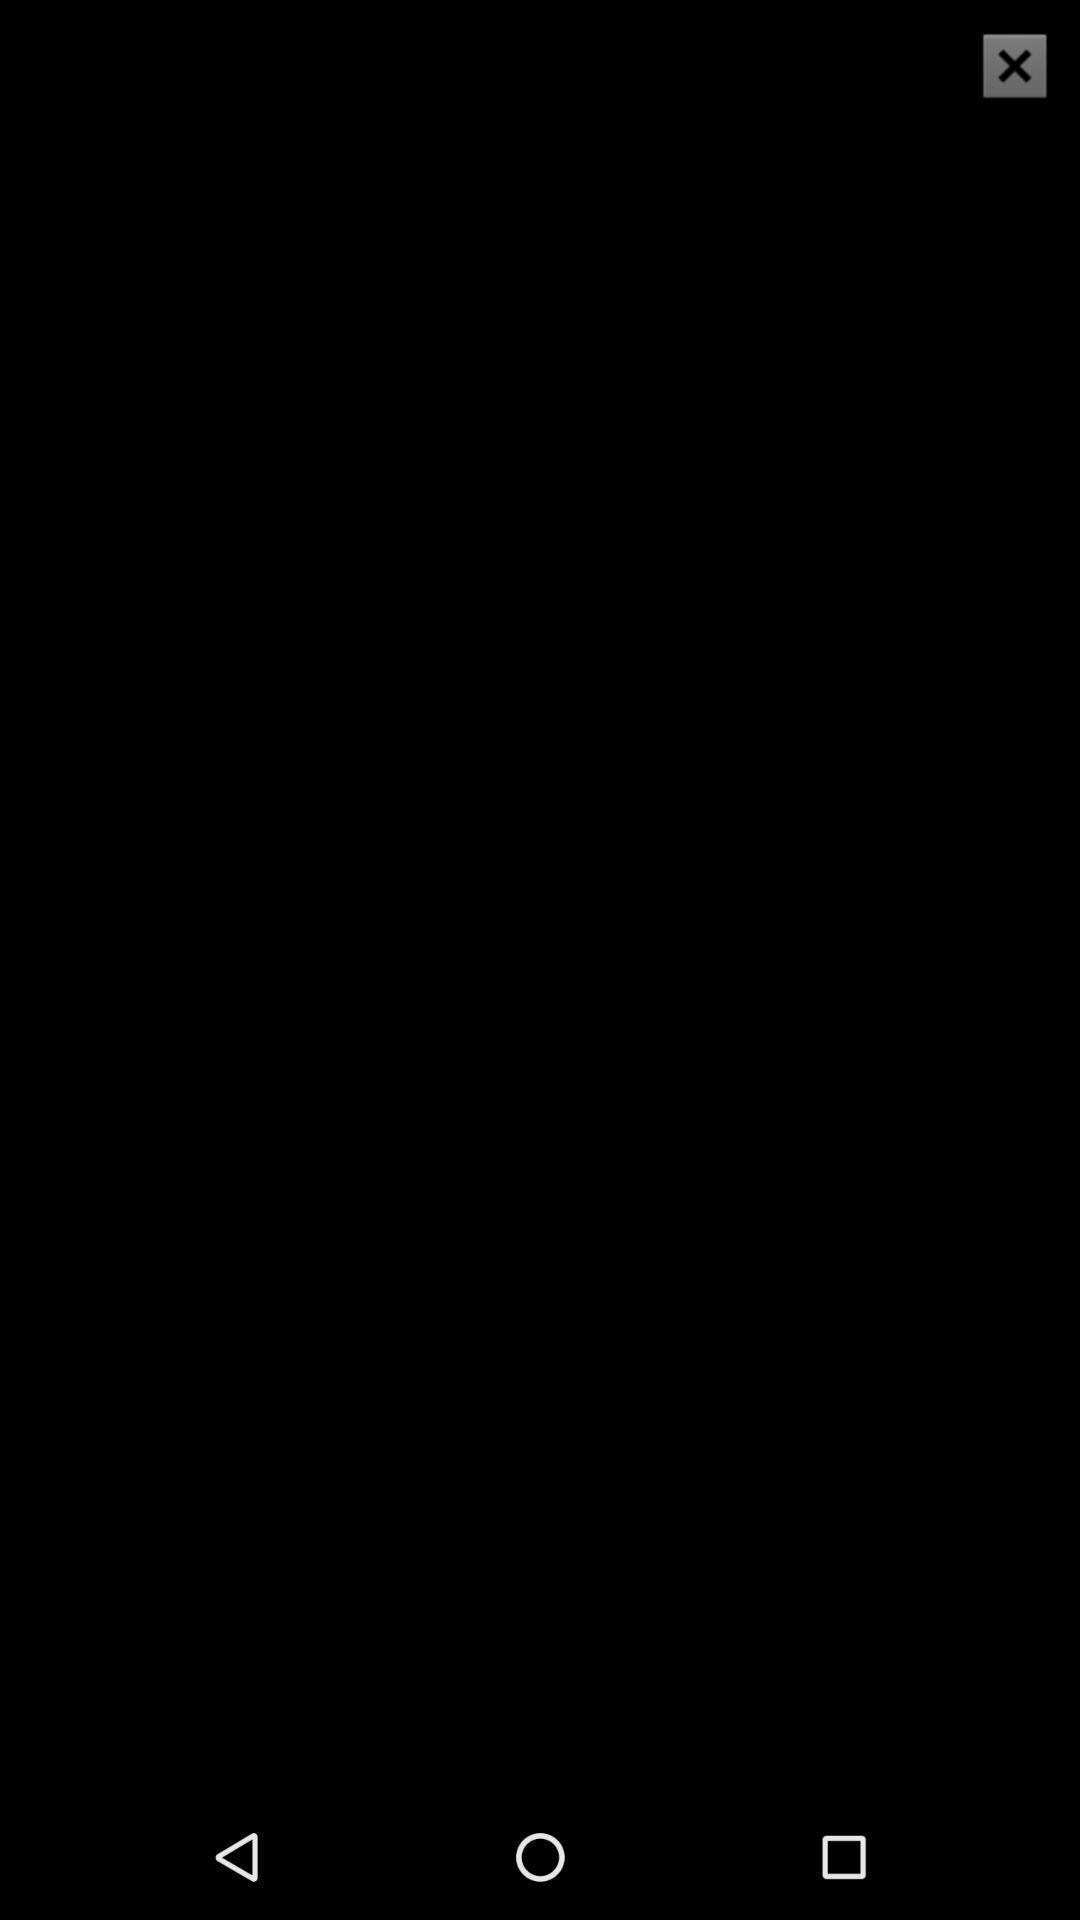Provide a description of this screenshot. Plage displaying blank image with close icon. 